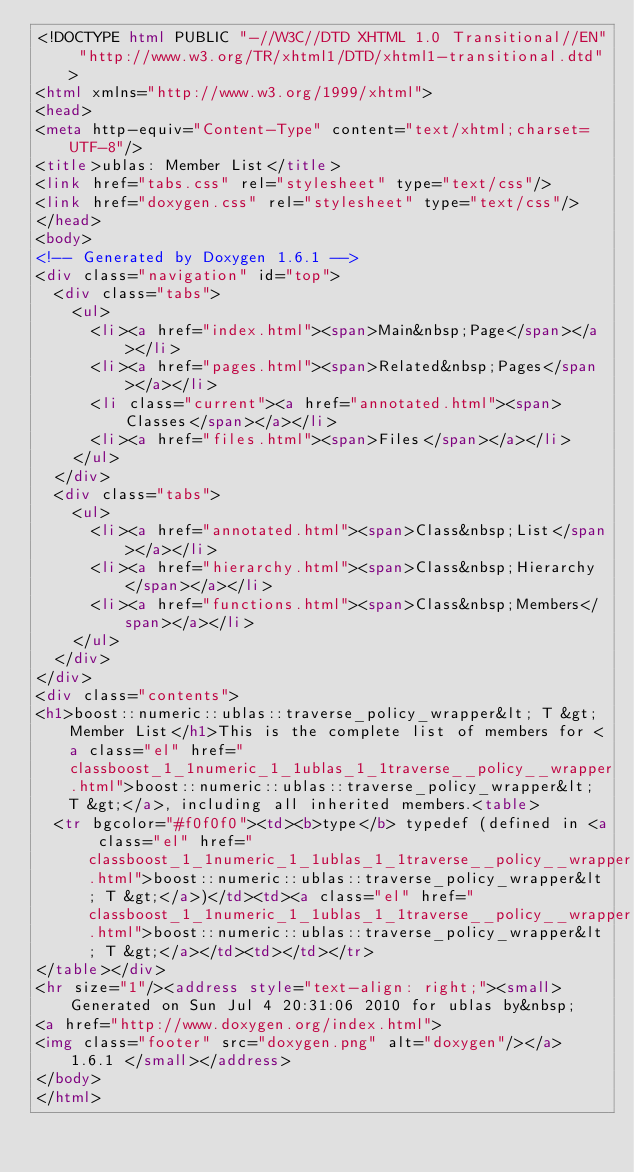Convert code to text. <code><loc_0><loc_0><loc_500><loc_500><_HTML_><!DOCTYPE html PUBLIC "-//W3C//DTD XHTML 1.0 Transitional//EN" "http://www.w3.org/TR/xhtml1/DTD/xhtml1-transitional.dtd">
<html xmlns="http://www.w3.org/1999/xhtml">
<head>
<meta http-equiv="Content-Type" content="text/xhtml;charset=UTF-8"/>
<title>ublas: Member List</title>
<link href="tabs.css" rel="stylesheet" type="text/css"/>
<link href="doxygen.css" rel="stylesheet" type="text/css"/>
</head>
<body>
<!-- Generated by Doxygen 1.6.1 -->
<div class="navigation" id="top">
  <div class="tabs">
    <ul>
      <li><a href="index.html"><span>Main&nbsp;Page</span></a></li>
      <li><a href="pages.html"><span>Related&nbsp;Pages</span></a></li>
      <li class="current"><a href="annotated.html"><span>Classes</span></a></li>
      <li><a href="files.html"><span>Files</span></a></li>
    </ul>
  </div>
  <div class="tabs">
    <ul>
      <li><a href="annotated.html"><span>Class&nbsp;List</span></a></li>
      <li><a href="hierarchy.html"><span>Class&nbsp;Hierarchy</span></a></li>
      <li><a href="functions.html"><span>Class&nbsp;Members</span></a></li>
    </ul>
  </div>
</div>
<div class="contents">
<h1>boost::numeric::ublas::traverse_policy_wrapper&lt; T &gt; Member List</h1>This is the complete list of members for <a class="el" href="classboost_1_1numeric_1_1ublas_1_1traverse__policy__wrapper.html">boost::numeric::ublas::traverse_policy_wrapper&lt; T &gt;</a>, including all inherited members.<table>
  <tr bgcolor="#f0f0f0"><td><b>type</b> typedef (defined in <a class="el" href="classboost_1_1numeric_1_1ublas_1_1traverse__policy__wrapper.html">boost::numeric::ublas::traverse_policy_wrapper&lt; T &gt;</a>)</td><td><a class="el" href="classboost_1_1numeric_1_1ublas_1_1traverse__policy__wrapper.html">boost::numeric::ublas::traverse_policy_wrapper&lt; T &gt;</a></td><td></td></tr>
</table></div>
<hr size="1"/><address style="text-align: right;"><small>Generated on Sun Jul 4 20:31:06 2010 for ublas by&nbsp;
<a href="http://www.doxygen.org/index.html">
<img class="footer" src="doxygen.png" alt="doxygen"/></a> 1.6.1 </small></address>
</body>
</html>
</code> 